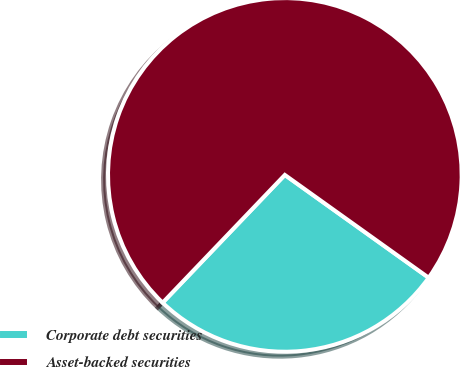<chart> <loc_0><loc_0><loc_500><loc_500><pie_chart><fcel>Corporate debt securities<fcel>Asset-backed securities<nl><fcel>27.27%<fcel>72.73%<nl></chart> 